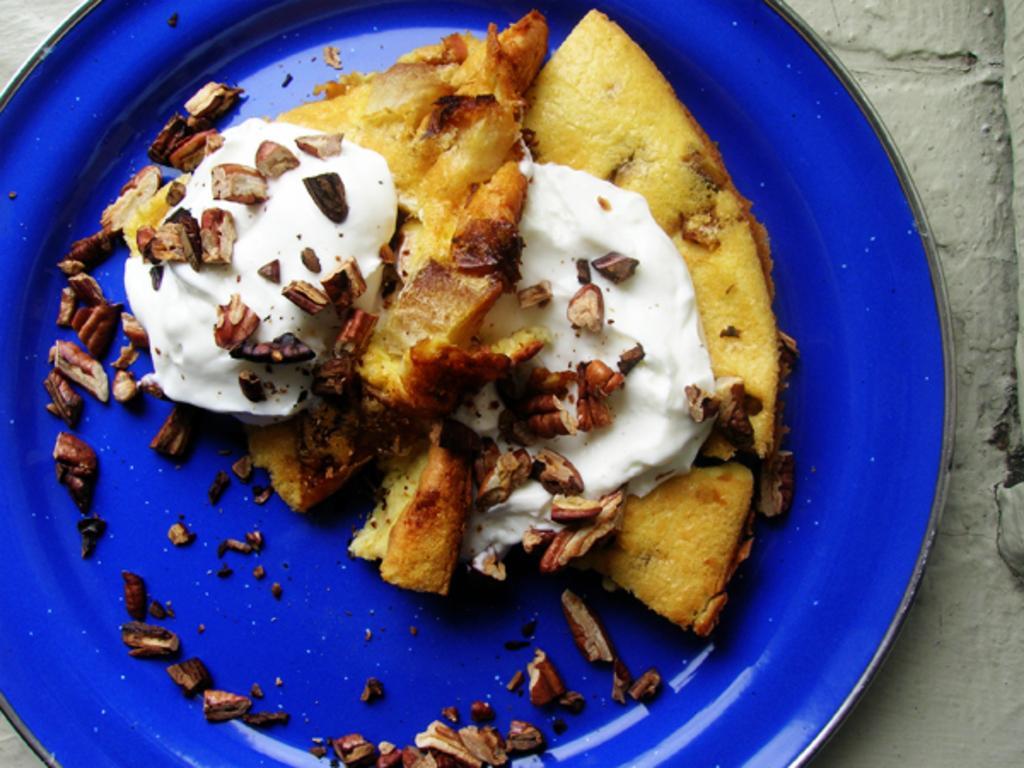How would you summarize this image in a sentence or two? In the picture there is some food item topped with cream and some nuts served on a plate. 